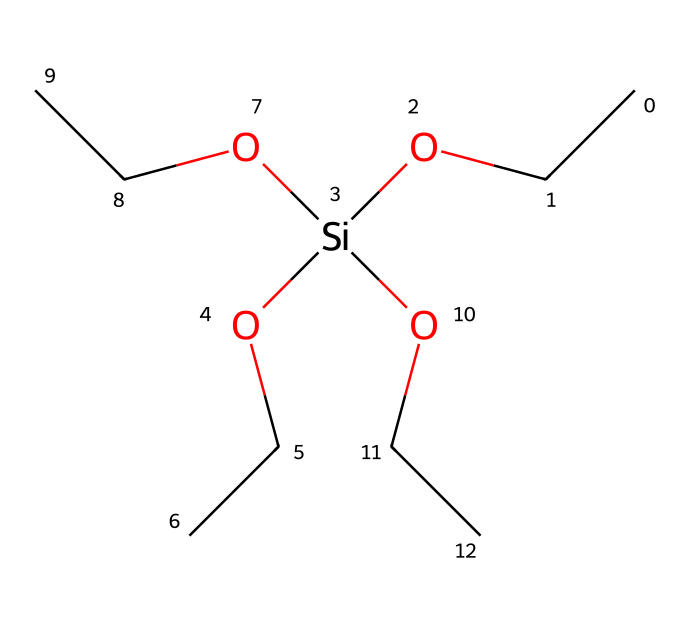What is the main functional group present in this compound? The structure shows -Si(OH)3, indicating the presence of silanol groups, which are typical functional groups for silane coupling agents.
Answer: silanol How many carbon atoms are in this molecule? By counting the carbon symbols (C) in the SMILES representation, there are six carbon atoms from the three -OCC groups and one carbon in the main structure.
Answer: six What type of bonding is mainly present between silicon and oxygen in this molecule? The SMILES representation shows silicon (Si) bonded with oxygen (O) through covalent bonds, as is typical in organosilicon compounds.
Answer: covalent What is the empirical formula derived from this structure? The SMILES indicates the presence of 6 carbons, 18 hydrogens, 3 oxygens, and 1 silicon, leading to the empirical formula C6H18O3Si.
Answer: C6H18O3Si How many hydroxyl (-OH) groups are attached to the silicon atom? The structure includes three -OH groups directly linked to the silicon atom, as shown by the three instances of O in the bonding pattern.
Answer: three What role do silane coupling agents play in construction materials? Silane coupling agents enhance the adhesion between organic materials and inorganic substrates, which is crucial in construction for better durability and bonding strength.
Answer: adhesion What type of reactions can silane coupling agents undergo due to their structure? The presence of silanol groups allows for reactions such as hydrolysis and condensation, facilitating bonding with surfaces and organics, essential for their function in construction.
Answer: hydrolysis and condensation 